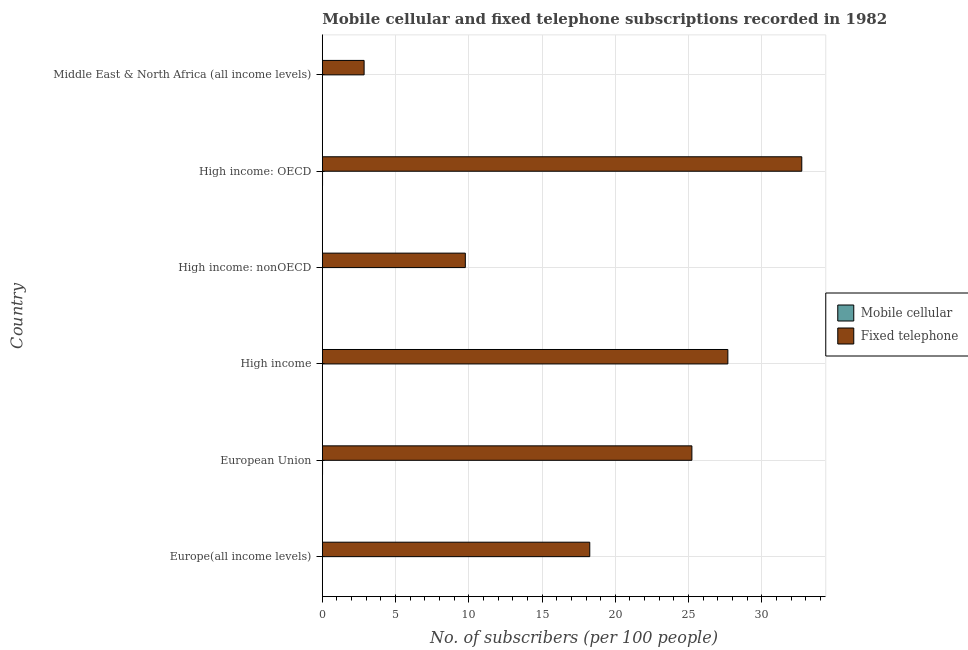How many groups of bars are there?
Offer a terse response. 6. Are the number of bars per tick equal to the number of legend labels?
Give a very brief answer. Yes. Are the number of bars on each tick of the Y-axis equal?
Ensure brevity in your answer.  Yes. How many bars are there on the 3rd tick from the top?
Make the answer very short. 2. What is the label of the 6th group of bars from the top?
Your answer should be compact. Europe(all income levels). In how many cases, is the number of bars for a given country not equal to the number of legend labels?
Make the answer very short. 0. What is the number of mobile cellular subscribers in High income: OECD?
Keep it short and to the point. 0.02. Across all countries, what is the maximum number of fixed telephone subscribers?
Offer a very short reply. 32.73. Across all countries, what is the minimum number of mobile cellular subscribers?
Ensure brevity in your answer.  0. In which country was the number of mobile cellular subscribers maximum?
Keep it short and to the point. High income: OECD. In which country was the number of mobile cellular subscribers minimum?
Give a very brief answer. High income: nonOECD. What is the total number of fixed telephone subscribers in the graph?
Give a very brief answer. 116.51. What is the difference between the number of fixed telephone subscribers in Europe(all income levels) and that in High income: OECD?
Provide a succinct answer. -14.47. What is the difference between the number of mobile cellular subscribers in High income and the number of fixed telephone subscribers in Europe(all income levels)?
Your answer should be compact. -18.24. What is the average number of fixed telephone subscribers per country?
Make the answer very short. 19.42. What is the difference between the number of fixed telephone subscribers and number of mobile cellular subscribers in High income?
Offer a very short reply. 27.67. In how many countries, is the number of mobile cellular subscribers greater than 10 ?
Ensure brevity in your answer.  0. What is the ratio of the number of mobile cellular subscribers in Europe(all income levels) to that in Middle East & North Africa (all income levels)?
Your answer should be compact. 7.87. What is the difference between the highest and the lowest number of fixed telephone subscribers?
Make the answer very short. 29.88. Is the sum of the number of mobile cellular subscribers in High income: OECD and High income: nonOECD greater than the maximum number of fixed telephone subscribers across all countries?
Make the answer very short. No. What does the 2nd bar from the top in High income represents?
Your answer should be very brief. Mobile cellular. What does the 1st bar from the bottom in High income represents?
Give a very brief answer. Mobile cellular. Are all the bars in the graph horizontal?
Keep it short and to the point. Yes. How many countries are there in the graph?
Provide a succinct answer. 6. Does the graph contain any zero values?
Ensure brevity in your answer.  No. Where does the legend appear in the graph?
Your response must be concise. Center right. How many legend labels are there?
Your answer should be very brief. 2. How are the legend labels stacked?
Give a very brief answer. Vertical. What is the title of the graph?
Offer a terse response. Mobile cellular and fixed telephone subscriptions recorded in 1982. What is the label or title of the X-axis?
Ensure brevity in your answer.  No. of subscribers (per 100 people). What is the label or title of the Y-axis?
Make the answer very short. Country. What is the No. of subscribers (per 100 people) in Mobile cellular in Europe(all income levels)?
Make the answer very short. 0.01. What is the No. of subscribers (per 100 people) in Fixed telephone in Europe(all income levels)?
Make the answer very short. 18.26. What is the No. of subscribers (per 100 people) of Mobile cellular in European Union?
Your response must be concise. 0.01. What is the No. of subscribers (per 100 people) in Fixed telephone in European Union?
Offer a terse response. 25.23. What is the No. of subscribers (per 100 people) in Mobile cellular in High income?
Ensure brevity in your answer.  0.01. What is the No. of subscribers (per 100 people) of Fixed telephone in High income?
Keep it short and to the point. 27.68. What is the No. of subscribers (per 100 people) in Mobile cellular in High income: nonOECD?
Your answer should be very brief. 0. What is the No. of subscribers (per 100 people) in Fixed telephone in High income: nonOECD?
Give a very brief answer. 9.76. What is the No. of subscribers (per 100 people) in Mobile cellular in High income: OECD?
Ensure brevity in your answer.  0.02. What is the No. of subscribers (per 100 people) in Fixed telephone in High income: OECD?
Your answer should be compact. 32.73. What is the No. of subscribers (per 100 people) of Mobile cellular in Middle East & North Africa (all income levels)?
Make the answer very short. 0. What is the No. of subscribers (per 100 people) of Fixed telephone in Middle East & North Africa (all income levels)?
Your answer should be very brief. 2.85. Across all countries, what is the maximum No. of subscribers (per 100 people) of Mobile cellular?
Your answer should be compact. 0.02. Across all countries, what is the maximum No. of subscribers (per 100 people) of Fixed telephone?
Keep it short and to the point. 32.73. Across all countries, what is the minimum No. of subscribers (per 100 people) in Mobile cellular?
Offer a terse response. 0. Across all countries, what is the minimum No. of subscribers (per 100 people) in Fixed telephone?
Offer a very short reply. 2.85. What is the total No. of subscribers (per 100 people) in Mobile cellular in the graph?
Offer a terse response. 0.05. What is the total No. of subscribers (per 100 people) in Fixed telephone in the graph?
Offer a very short reply. 116.5. What is the difference between the No. of subscribers (per 100 people) of Mobile cellular in Europe(all income levels) and that in European Union?
Your answer should be very brief. -0. What is the difference between the No. of subscribers (per 100 people) of Fixed telephone in Europe(all income levels) and that in European Union?
Your answer should be very brief. -6.97. What is the difference between the No. of subscribers (per 100 people) in Mobile cellular in Europe(all income levels) and that in High income?
Offer a terse response. -0. What is the difference between the No. of subscribers (per 100 people) of Fixed telephone in Europe(all income levels) and that in High income?
Keep it short and to the point. -9.43. What is the difference between the No. of subscribers (per 100 people) of Mobile cellular in Europe(all income levels) and that in High income: nonOECD?
Offer a very short reply. 0.01. What is the difference between the No. of subscribers (per 100 people) of Fixed telephone in Europe(all income levels) and that in High income: nonOECD?
Your answer should be compact. 8.49. What is the difference between the No. of subscribers (per 100 people) in Mobile cellular in Europe(all income levels) and that in High income: OECD?
Provide a short and direct response. -0.01. What is the difference between the No. of subscribers (per 100 people) of Fixed telephone in Europe(all income levels) and that in High income: OECD?
Give a very brief answer. -14.47. What is the difference between the No. of subscribers (per 100 people) of Mobile cellular in Europe(all income levels) and that in Middle East & North Africa (all income levels)?
Ensure brevity in your answer.  0.01. What is the difference between the No. of subscribers (per 100 people) in Fixed telephone in Europe(all income levels) and that in Middle East & North Africa (all income levels)?
Provide a succinct answer. 15.4. What is the difference between the No. of subscribers (per 100 people) in Mobile cellular in European Union and that in High income?
Give a very brief answer. 0. What is the difference between the No. of subscribers (per 100 people) in Fixed telephone in European Union and that in High income?
Ensure brevity in your answer.  -2.46. What is the difference between the No. of subscribers (per 100 people) in Mobile cellular in European Union and that in High income: nonOECD?
Your answer should be very brief. 0.01. What is the difference between the No. of subscribers (per 100 people) of Fixed telephone in European Union and that in High income: nonOECD?
Offer a terse response. 15.47. What is the difference between the No. of subscribers (per 100 people) in Mobile cellular in European Union and that in High income: OECD?
Provide a short and direct response. -0. What is the difference between the No. of subscribers (per 100 people) of Fixed telephone in European Union and that in High income: OECD?
Keep it short and to the point. -7.5. What is the difference between the No. of subscribers (per 100 people) of Mobile cellular in European Union and that in Middle East & North Africa (all income levels)?
Provide a short and direct response. 0.01. What is the difference between the No. of subscribers (per 100 people) of Fixed telephone in European Union and that in Middle East & North Africa (all income levels)?
Give a very brief answer. 22.37. What is the difference between the No. of subscribers (per 100 people) in Mobile cellular in High income and that in High income: nonOECD?
Your response must be concise. 0.01. What is the difference between the No. of subscribers (per 100 people) of Fixed telephone in High income and that in High income: nonOECD?
Keep it short and to the point. 17.92. What is the difference between the No. of subscribers (per 100 people) of Mobile cellular in High income and that in High income: OECD?
Offer a very short reply. -0. What is the difference between the No. of subscribers (per 100 people) in Fixed telephone in High income and that in High income: OECD?
Offer a terse response. -5.05. What is the difference between the No. of subscribers (per 100 people) of Mobile cellular in High income and that in Middle East & North Africa (all income levels)?
Offer a terse response. 0.01. What is the difference between the No. of subscribers (per 100 people) of Fixed telephone in High income and that in Middle East & North Africa (all income levels)?
Make the answer very short. 24.83. What is the difference between the No. of subscribers (per 100 people) of Mobile cellular in High income: nonOECD and that in High income: OECD?
Keep it short and to the point. -0.01. What is the difference between the No. of subscribers (per 100 people) of Fixed telephone in High income: nonOECD and that in High income: OECD?
Your answer should be compact. -22.97. What is the difference between the No. of subscribers (per 100 people) in Mobile cellular in High income: nonOECD and that in Middle East & North Africa (all income levels)?
Provide a succinct answer. -0. What is the difference between the No. of subscribers (per 100 people) of Fixed telephone in High income: nonOECD and that in Middle East & North Africa (all income levels)?
Provide a short and direct response. 6.91. What is the difference between the No. of subscribers (per 100 people) in Mobile cellular in High income: OECD and that in Middle East & North Africa (all income levels)?
Ensure brevity in your answer.  0.01. What is the difference between the No. of subscribers (per 100 people) in Fixed telephone in High income: OECD and that in Middle East & North Africa (all income levels)?
Offer a terse response. 29.88. What is the difference between the No. of subscribers (per 100 people) of Mobile cellular in Europe(all income levels) and the No. of subscribers (per 100 people) of Fixed telephone in European Union?
Provide a short and direct response. -25.22. What is the difference between the No. of subscribers (per 100 people) of Mobile cellular in Europe(all income levels) and the No. of subscribers (per 100 people) of Fixed telephone in High income?
Offer a terse response. -27.67. What is the difference between the No. of subscribers (per 100 people) of Mobile cellular in Europe(all income levels) and the No. of subscribers (per 100 people) of Fixed telephone in High income: nonOECD?
Your answer should be very brief. -9.75. What is the difference between the No. of subscribers (per 100 people) of Mobile cellular in Europe(all income levels) and the No. of subscribers (per 100 people) of Fixed telephone in High income: OECD?
Offer a terse response. -32.72. What is the difference between the No. of subscribers (per 100 people) of Mobile cellular in Europe(all income levels) and the No. of subscribers (per 100 people) of Fixed telephone in Middle East & North Africa (all income levels)?
Your answer should be very brief. -2.84. What is the difference between the No. of subscribers (per 100 people) in Mobile cellular in European Union and the No. of subscribers (per 100 people) in Fixed telephone in High income?
Your response must be concise. -27.67. What is the difference between the No. of subscribers (per 100 people) in Mobile cellular in European Union and the No. of subscribers (per 100 people) in Fixed telephone in High income: nonOECD?
Ensure brevity in your answer.  -9.75. What is the difference between the No. of subscribers (per 100 people) in Mobile cellular in European Union and the No. of subscribers (per 100 people) in Fixed telephone in High income: OECD?
Your answer should be very brief. -32.71. What is the difference between the No. of subscribers (per 100 people) of Mobile cellular in European Union and the No. of subscribers (per 100 people) of Fixed telephone in Middle East & North Africa (all income levels)?
Your answer should be very brief. -2.84. What is the difference between the No. of subscribers (per 100 people) of Mobile cellular in High income and the No. of subscribers (per 100 people) of Fixed telephone in High income: nonOECD?
Provide a succinct answer. -9.75. What is the difference between the No. of subscribers (per 100 people) of Mobile cellular in High income and the No. of subscribers (per 100 people) of Fixed telephone in High income: OECD?
Your answer should be compact. -32.72. What is the difference between the No. of subscribers (per 100 people) in Mobile cellular in High income and the No. of subscribers (per 100 people) in Fixed telephone in Middle East & North Africa (all income levels)?
Ensure brevity in your answer.  -2.84. What is the difference between the No. of subscribers (per 100 people) in Mobile cellular in High income: nonOECD and the No. of subscribers (per 100 people) in Fixed telephone in High income: OECD?
Give a very brief answer. -32.73. What is the difference between the No. of subscribers (per 100 people) of Mobile cellular in High income: nonOECD and the No. of subscribers (per 100 people) of Fixed telephone in Middle East & North Africa (all income levels)?
Make the answer very short. -2.85. What is the difference between the No. of subscribers (per 100 people) of Mobile cellular in High income: OECD and the No. of subscribers (per 100 people) of Fixed telephone in Middle East & North Africa (all income levels)?
Keep it short and to the point. -2.84. What is the average No. of subscribers (per 100 people) in Mobile cellular per country?
Provide a short and direct response. 0.01. What is the average No. of subscribers (per 100 people) of Fixed telephone per country?
Provide a succinct answer. 19.42. What is the difference between the No. of subscribers (per 100 people) of Mobile cellular and No. of subscribers (per 100 people) of Fixed telephone in Europe(all income levels)?
Offer a terse response. -18.25. What is the difference between the No. of subscribers (per 100 people) in Mobile cellular and No. of subscribers (per 100 people) in Fixed telephone in European Union?
Provide a short and direct response. -25.21. What is the difference between the No. of subscribers (per 100 people) of Mobile cellular and No. of subscribers (per 100 people) of Fixed telephone in High income?
Your answer should be very brief. -27.67. What is the difference between the No. of subscribers (per 100 people) of Mobile cellular and No. of subscribers (per 100 people) of Fixed telephone in High income: nonOECD?
Your answer should be very brief. -9.76. What is the difference between the No. of subscribers (per 100 people) of Mobile cellular and No. of subscribers (per 100 people) of Fixed telephone in High income: OECD?
Offer a very short reply. -32.71. What is the difference between the No. of subscribers (per 100 people) in Mobile cellular and No. of subscribers (per 100 people) in Fixed telephone in Middle East & North Africa (all income levels)?
Keep it short and to the point. -2.85. What is the ratio of the No. of subscribers (per 100 people) of Mobile cellular in Europe(all income levels) to that in European Union?
Make the answer very short. 0.68. What is the ratio of the No. of subscribers (per 100 people) in Fixed telephone in Europe(all income levels) to that in European Union?
Your answer should be very brief. 0.72. What is the ratio of the No. of subscribers (per 100 people) in Mobile cellular in Europe(all income levels) to that in High income?
Your answer should be compact. 0.87. What is the ratio of the No. of subscribers (per 100 people) of Fixed telephone in Europe(all income levels) to that in High income?
Give a very brief answer. 0.66. What is the ratio of the No. of subscribers (per 100 people) in Mobile cellular in Europe(all income levels) to that in High income: nonOECD?
Provide a succinct answer. 10.17. What is the ratio of the No. of subscribers (per 100 people) in Fixed telephone in Europe(all income levels) to that in High income: nonOECD?
Give a very brief answer. 1.87. What is the ratio of the No. of subscribers (per 100 people) of Mobile cellular in Europe(all income levels) to that in High income: OECD?
Provide a succinct answer. 0.65. What is the ratio of the No. of subscribers (per 100 people) in Fixed telephone in Europe(all income levels) to that in High income: OECD?
Ensure brevity in your answer.  0.56. What is the ratio of the No. of subscribers (per 100 people) of Mobile cellular in Europe(all income levels) to that in Middle East & North Africa (all income levels)?
Give a very brief answer. 7.87. What is the ratio of the No. of subscribers (per 100 people) in Fixed telephone in Europe(all income levels) to that in Middle East & North Africa (all income levels)?
Give a very brief answer. 6.4. What is the ratio of the No. of subscribers (per 100 people) in Mobile cellular in European Union to that in High income?
Provide a short and direct response. 1.27. What is the ratio of the No. of subscribers (per 100 people) of Fixed telephone in European Union to that in High income?
Your answer should be very brief. 0.91. What is the ratio of the No. of subscribers (per 100 people) of Mobile cellular in European Union to that in High income: nonOECD?
Your answer should be very brief. 14.89. What is the ratio of the No. of subscribers (per 100 people) in Fixed telephone in European Union to that in High income: nonOECD?
Your answer should be compact. 2.58. What is the ratio of the No. of subscribers (per 100 people) in Mobile cellular in European Union to that in High income: OECD?
Ensure brevity in your answer.  0.95. What is the ratio of the No. of subscribers (per 100 people) in Fixed telephone in European Union to that in High income: OECD?
Your response must be concise. 0.77. What is the ratio of the No. of subscribers (per 100 people) of Mobile cellular in European Union to that in Middle East & North Africa (all income levels)?
Your answer should be very brief. 11.52. What is the ratio of the No. of subscribers (per 100 people) in Fixed telephone in European Union to that in Middle East & North Africa (all income levels)?
Provide a succinct answer. 8.84. What is the ratio of the No. of subscribers (per 100 people) of Mobile cellular in High income to that in High income: nonOECD?
Your response must be concise. 11.7. What is the ratio of the No. of subscribers (per 100 people) in Fixed telephone in High income to that in High income: nonOECD?
Offer a terse response. 2.84. What is the ratio of the No. of subscribers (per 100 people) in Mobile cellular in High income to that in High income: OECD?
Offer a terse response. 0.75. What is the ratio of the No. of subscribers (per 100 people) of Fixed telephone in High income to that in High income: OECD?
Your response must be concise. 0.85. What is the ratio of the No. of subscribers (per 100 people) of Mobile cellular in High income to that in Middle East & North Africa (all income levels)?
Ensure brevity in your answer.  9.05. What is the ratio of the No. of subscribers (per 100 people) in Fixed telephone in High income to that in Middle East & North Africa (all income levels)?
Provide a succinct answer. 9.7. What is the ratio of the No. of subscribers (per 100 people) in Mobile cellular in High income: nonOECD to that in High income: OECD?
Offer a terse response. 0.06. What is the ratio of the No. of subscribers (per 100 people) in Fixed telephone in High income: nonOECD to that in High income: OECD?
Provide a short and direct response. 0.3. What is the ratio of the No. of subscribers (per 100 people) of Mobile cellular in High income: nonOECD to that in Middle East & North Africa (all income levels)?
Provide a succinct answer. 0.77. What is the ratio of the No. of subscribers (per 100 people) of Fixed telephone in High income: nonOECD to that in Middle East & North Africa (all income levels)?
Keep it short and to the point. 3.42. What is the ratio of the No. of subscribers (per 100 people) in Mobile cellular in High income: OECD to that in Middle East & North Africa (all income levels)?
Ensure brevity in your answer.  12.09. What is the ratio of the No. of subscribers (per 100 people) of Fixed telephone in High income: OECD to that in Middle East & North Africa (all income levels)?
Your response must be concise. 11.47. What is the difference between the highest and the second highest No. of subscribers (per 100 people) of Mobile cellular?
Make the answer very short. 0. What is the difference between the highest and the second highest No. of subscribers (per 100 people) of Fixed telephone?
Provide a succinct answer. 5.05. What is the difference between the highest and the lowest No. of subscribers (per 100 people) in Mobile cellular?
Provide a succinct answer. 0.01. What is the difference between the highest and the lowest No. of subscribers (per 100 people) in Fixed telephone?
Give a very brief answer. 29.88. 